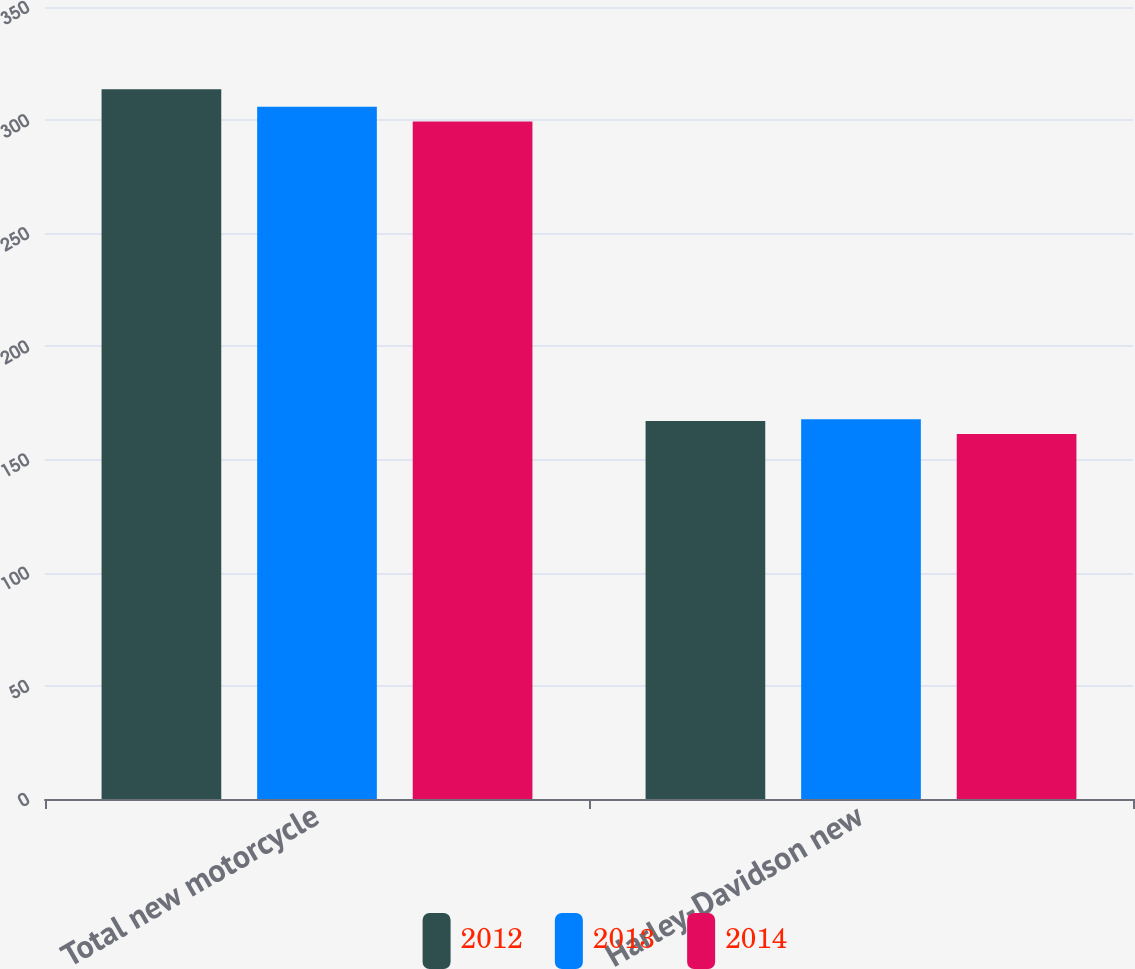<chart> <loc_0><loc_0><loc_500><loc_500><stacked_bar_chart><ecel><fcel>Total new motorcycle<fcel>Harley-Davidson new<nl><fcel>2012<fcel>313.6<fcel>167.1<nl><fcel>2013<fcel>305.9<fcel>167.8<nl><fcel>2014<fcel>299.4<fcel>161.3<nl></chart> 